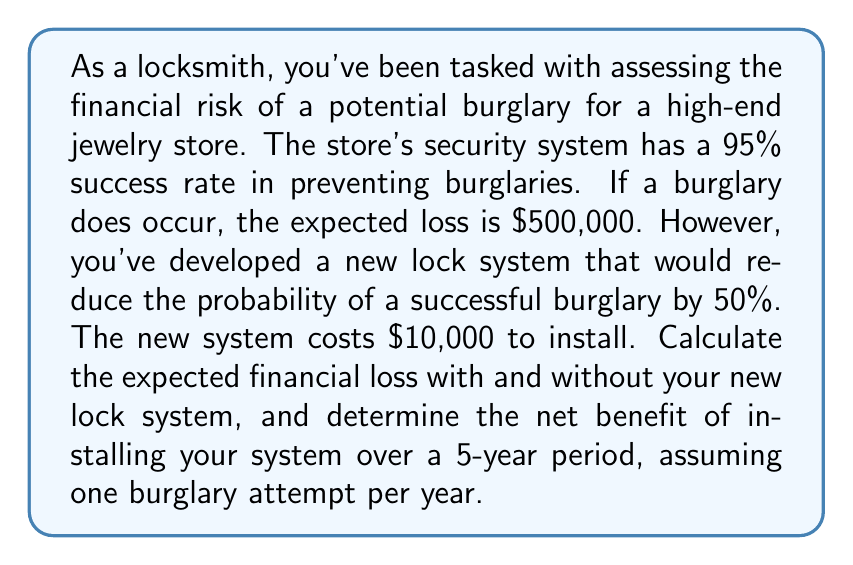Give your solution to this math problem. Let's break this down step-by-step:

1) First, let's calculate the probability of a successful burglary:
   Without new system: $P(\text{success}) = 1 - 0.95 = 0.05$ or 5%
   With new system: $P(\text{success}) = 0.05 \times 0.5 = 0.025$ or 2.5%

2) Now, let's calculate the expected loss per year:
   Without new system: $E(\text{loss}) = 0.05 \times \$500,000 = \$25,000$
   With new system: $E(\text{loss}) = 0.025 \times \$500,000 = \$12,500$

3) Over 5 years:
   Without new system: $5 \times \$25,000 = \$125,000$
   With new system: $(5 \times \$12,500) + \$10,000 = \$72,500$

4) The net benefit over 5 years is the difference between these two:
   $\$125,000 - \$72,500 = \$52,500$

To formalize this in financial mathematics terms:

Let $p$ be the probability of a successful burglary without the new system,
$L$ be the loss from a successful burglary,
$r$ be the reduction factor of the new system,
$C$ be the cost of the new system,
and $n$ be the number of years.

Then the expected loss without the new system over $n$ years is:

$$E(\text{Loss}_{\text{without}}) = n \times p \times L$$

And with the new system:

$$E(\text{Loss}_{\text{with}}) = n \times p \times r \times L + C$$

The net benefit is:

$$\text{Net Benefit} = E(\text{Loss}_{\text{without}}) - E(\text{Loss}_{\text{with}})$$

$$= n \times p \times L - (n \times p \times r \times L + C)$$
$$= n \times p \times L \times (1-r) - C$$

Plugging in our values:
$$\text{Net Benefit} = 5 \times 0.05 \times \$500,000 \times (1-0.5) - \$10,000 = \$52,500$$
Answer: The expected financial loss without the new lock system over 5 years is $125,000. The expected financial loss with the new lock system over 5 years is $72,500. The net benefit of installing the new lock system over a 5-year period is $52,500. 